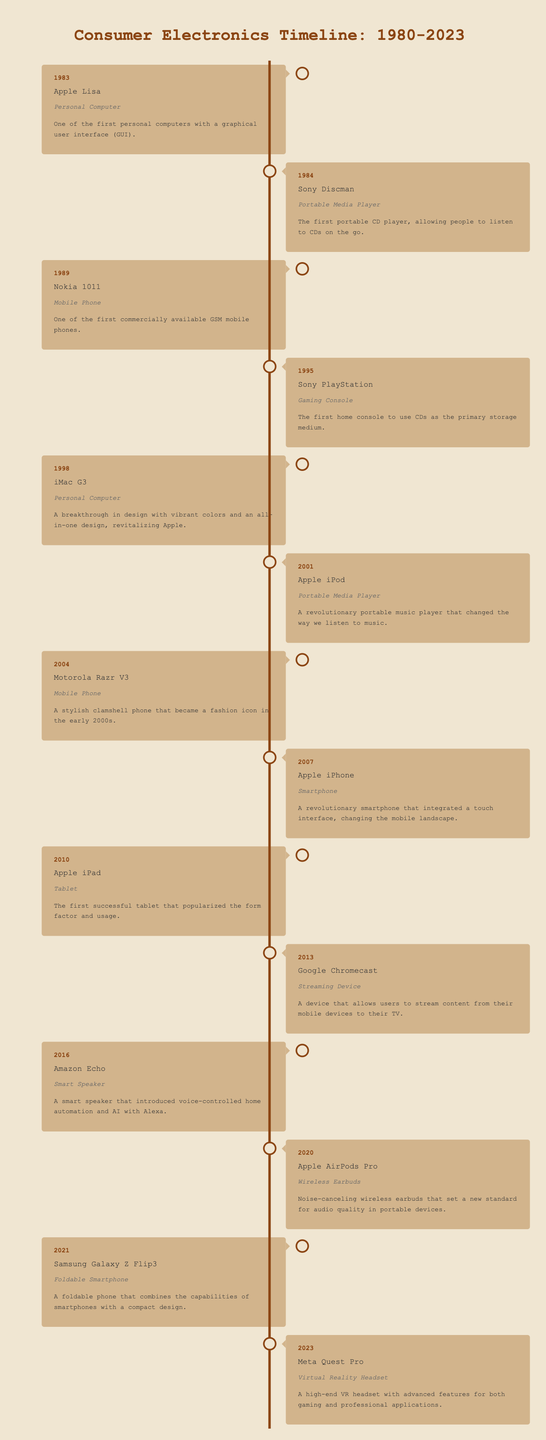What was the first portable media player released? The table lists innovations starting from 1983, and the first entry under the Portable Media Player category is the Sony Discman, released in 1984.
Answer: Sony Discman Which innovation was released in the year 2001? In the table, the entry for the year 2001 lists the Apple iPod as the innovation for that year.
Answer: Apple iPod How many mobile phone innovations are listed in the table? By counting the entries in the Mobile Phone category, there are three innovations: Nokia 1011 (1989), Motorola Razr V3 (2004), and Samsung Galaxy Z Flip3 (2021).
Answer: 3 What innovation was the last released before 2010? The last entry before 2010 is for the year 2007, which is the Apple iPhone.
Answer: Apple iPhone Which innovation introduced voice-controlled home automation? According to the table, the Amazon Echo, released in 2016, is noted for introducing voice-controlled home automation.
Answer: Amazon Echo Was the iMac G3 a personal computer? Yes, the table classifies the iMac G3, released in 1998, as a personal computer.
Answer: Yes How many years apart were the Sony PlayStation and Apple iPod releases? The Sony PlayStation was released in 1995, and the Apple iPod was released in 2001. Calculating the difference: 2001 - 1995 = 6 years apart.
Answer: 6 years Which innovation was released in the same year as the launch of the first successful tablet? The table shows that the Apple iPad, launched in 2010, was the first successful tablet. There are no other innovations from that year listed, thus it is the only innovation.
Answer: Apple iPad Identify one major innovation in streaming devices. The table specifies Google Chromecast as the innovation for streaming devices, released in 2013.
Answer: Google Chromecast Which categories contain innovations released in the early 2000s (2000 – 2009)? In the early 2000s, the table lists the following innovations: Apple iPod (2001), Motorola Razr V3 (2004), and the Apple iPhone (2007). All belong to various categories such as Portable Media Player and Mobile Phone.
Answer: Details vary across categories What is the average release year of the innovations listed? To find the average, total the years (1983 + 1984 + 1989 + 1995 + 1998 + 2001 + 2004 + 2007 + 2010 + 2013 + 2016 + 2020 + 2021 + 2023 =  2017), then divide by the number of innovations listed (14): 2017 / 14 ≈ 143.36, rounded to the nearest whole number gives approximately 2017.
Answer: 2017 What is the most recent innovation in the table? The table shows the most recent innovation listed is the Meta Quest Pro, released in 2023.
Answer: Meta Quest Pro 